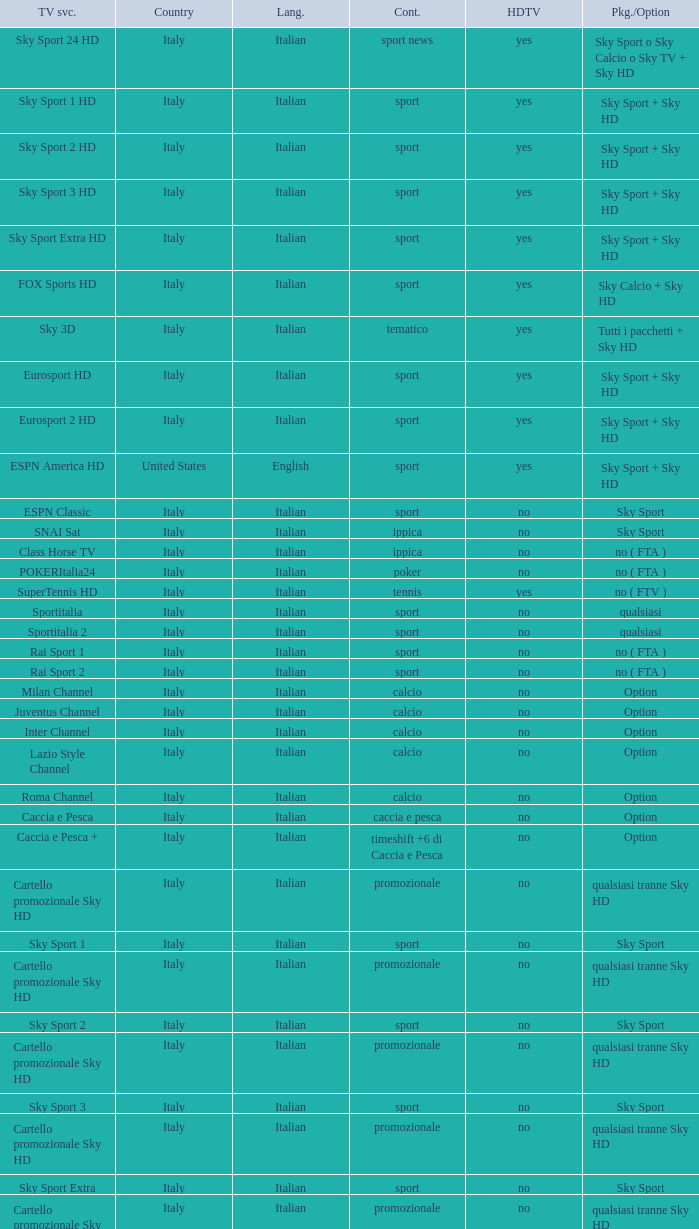What is Package/Option, when Content is Tennis? No ( ftv ). Help me parse the entirety of this table. {'header': ['TV svc.', 'Country', 'Lang.', 'Cont.', 'HDTV', 'Pkg./Option'], 'rows': [['Sky Sport 24 HD', 'Italy', 'Italian', 'sport news', 'yes', 'Sky Sport o Sky Calcio o Sky TV + Sky HD'], ['Sky Sport 1 HD', 'Italy', 'Italian', 'sport', 'yes', 'Sky Sport + Sky HD'], ['Sky Sport 2 HD', 'Italy', 'Italian', 'sport', 'yes', 'Sky Sport + Sky HD'], ['Sky Sport 3 HD', 'Italy', 'Italian', 'sport', 'yes', 'Sky Sport + Sky HD'], ['Sky Sport Extra HD', 'Italy', 'Italian', 'sport', 'yes', 'Sky Sport + Sky HD'], ['FOX Sports HD', 'Italy', 'Italian', 'sport', 'yes', 'Sky Calcio + Sky HD'], ['Sky 3D', 'Italy', 'Italian', 'tematico', 'yes', 'Tutti i pacchetti + Sky HD'], ['Eurosport HD', 'Italy', 'Italian', 'sport', 'yes', 'Sky Sport + Sky HD'], ['Eurosport 2 HD', 'Italy', 'Italian', 'sport', 'yes', 'Sky Sport + Sky HD'], ['ESPN America HD', 'United States', 'English', 'sport', 'yes', 'Sky Sport + Sky HD'], ['ESPN Classic', 'Italy', 'Italian', 'sport', 'no', 'Sky Sport'], ['SNAI Sat', 'Italy', 'Italian', 'ippica', 'no', 'Sky Sport'], ['Class Horse TV', 'Italy', 'Italian', 'ippica', 'no', 'no ( FTA )'], ['POKERItalia24', 'Italy', 'Italian', 'poker', 'no', 'no ( FTA )'], ['SuperTennis HD', 'Italy', 'Italian', 'tennis', 'yes', 'no ( FTV )'], ['Sportitalia', 'Italy', 'Italian', 'sport', 'no', 'qualsiasi'], ['Sportitalia 2', 'Italy', 'Italian', 'sport', 'no', 'qualsiasi'], ['Rai Sport 1', 'Italy', 'Italian', 'sport', 'no', 'no ( FTA )'], ['Rai Sport 2', 'Italy', 'Italian', 'sport', 'no', 'no ( FTA )'], ['Milan Channel', 'Italy', 'Italian', 'calcio', 'no', 'Option'], ['Juventus Channel', 'Italy', 'Italian', 'calcio', 'no', 'Option'], ['Inter Channel', 'Italy', 'Italian', 'calcio', 'no', 'Option'], ['Lazio Style Channel', 'Italy', 'Italian', 'calcio', 'no', 'Option'], ['Roma Channel', 'Italy', 'Italian', 'calcio', 'no', 'Option'], ['Caccia e Pesca', 'Italy', 'Italian', 'caccia e pesca', 'no', 'Option'], ['Caccia e Pesca +', 'Italy', 'Italian', 'timeshift +6 di Caccia e Pesca', 'no', 'Option'], ['Cartello promozionale Sky HD', 'Italy', 'Italian', 'promozionale', 'no', 'qualsiasi tranne Sky HD'], ['Sky Sport 1', 'Italy', 'Italian', 'sport', 'no', 'Sky Sport'], ['Cartello promozionale Sky HD', 'Italy', 'Italian', 'promozionale', 'no', 'qualsiasi tranne Sky HD'], ['Sky Sport 2', 'Italy', 'Italian', 'sport', 'no', 'Sky Sport'], ['Cartello promozionale Sky HD', 'Italy', 'Italian', 'promozionale', 'no', 'qualsiasi tranne Sky HD'], ['Sky Sport 3', 'Italy', 'Italian', 'sport', 'no', 'Sky Sport'], ['Cartello promozionale Sky HD', 'Italy', 'Italian', 'promozionale', 'no', 'qualsiasi tranne Sky HD'], ['Sky Sport Extra', 'Italy', 'Italian', 'sport', 'no', 'Sky Sport'], ['Cartello promozionale Sky HD', 'Italy', 'Italian', 'promozionale', 'no', 'qualsiasi tranne Sky HD'], ['Sky Supercalcio', 'Italy', 'Italian', 'calcio', 'no', 'Sky Calcio'], ['Cartello promozionale Sky HD', 'Italy', 'Italian', 'promozionale', 'no', 'qualsiasi tranne Sky HD'], ['Eurosport', 'Italy', 'Italian', 'sport', 'no', 'Sky Sport'], ['Eurosport 2', 'Italy', 'Italian', 'sport', 'no', 'Sky Sport'], ['ESPN America', 'Italy', 'Italian', 'sport', 'no', 'Sky Sport']]} 